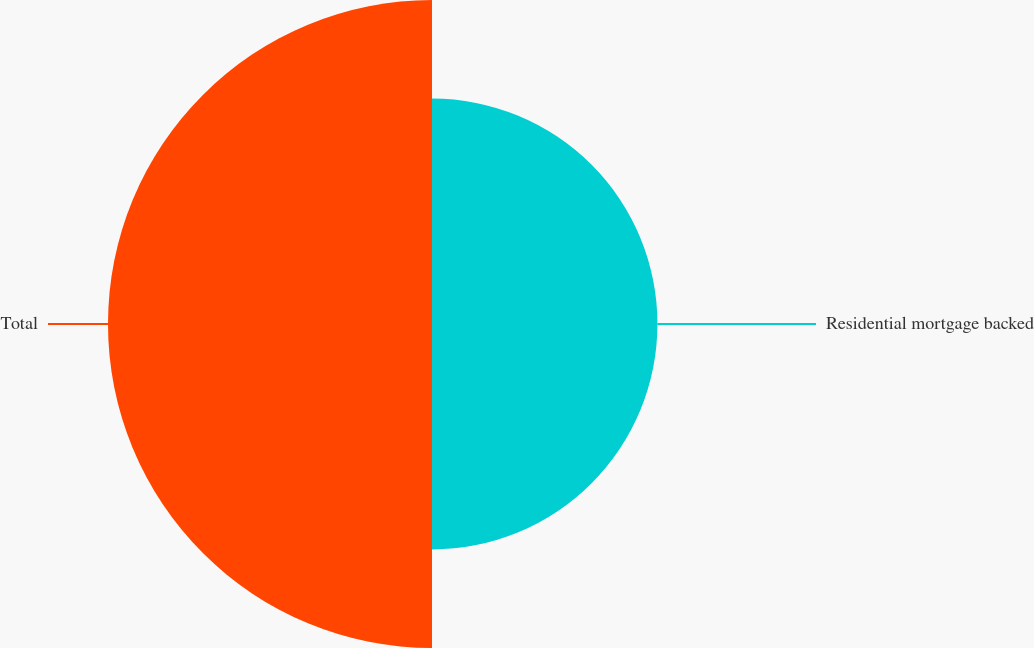Convert chart. <chart><loc_0><loc_0><loc_500><loc_500><pie_chart><fcel>Residential mortgage backed<fcel>Total<nl><fcel>41.03%<fcel>58.97%<nl></chart> 